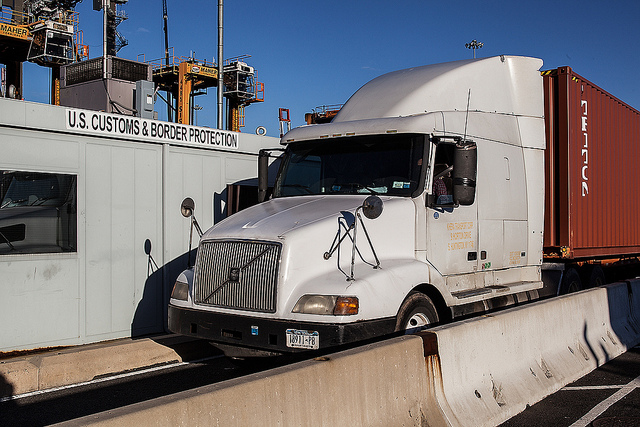What could be the primary purpose of the inspection booth at the border? The primary function of the customs border inspection booth, as seen in the image where a white semi-truck is approaching the checkpoint, is to control and oversee the movement of goods, vehicles, and individuals across the border. The booth, clearly marked with 'U.S. Customs and Border Protection', is a crucial point for enforcing legal and regulatory requirements. Agents here verify transport and cargo papers to ensure everything meets the country's import/export laws and assess the truck for any prohibited or undeclared items. This meticulous procedure helps in safeguarding national security, preventing illicit activities like smuggling, and protecting the local economy from illegal trade practices. 